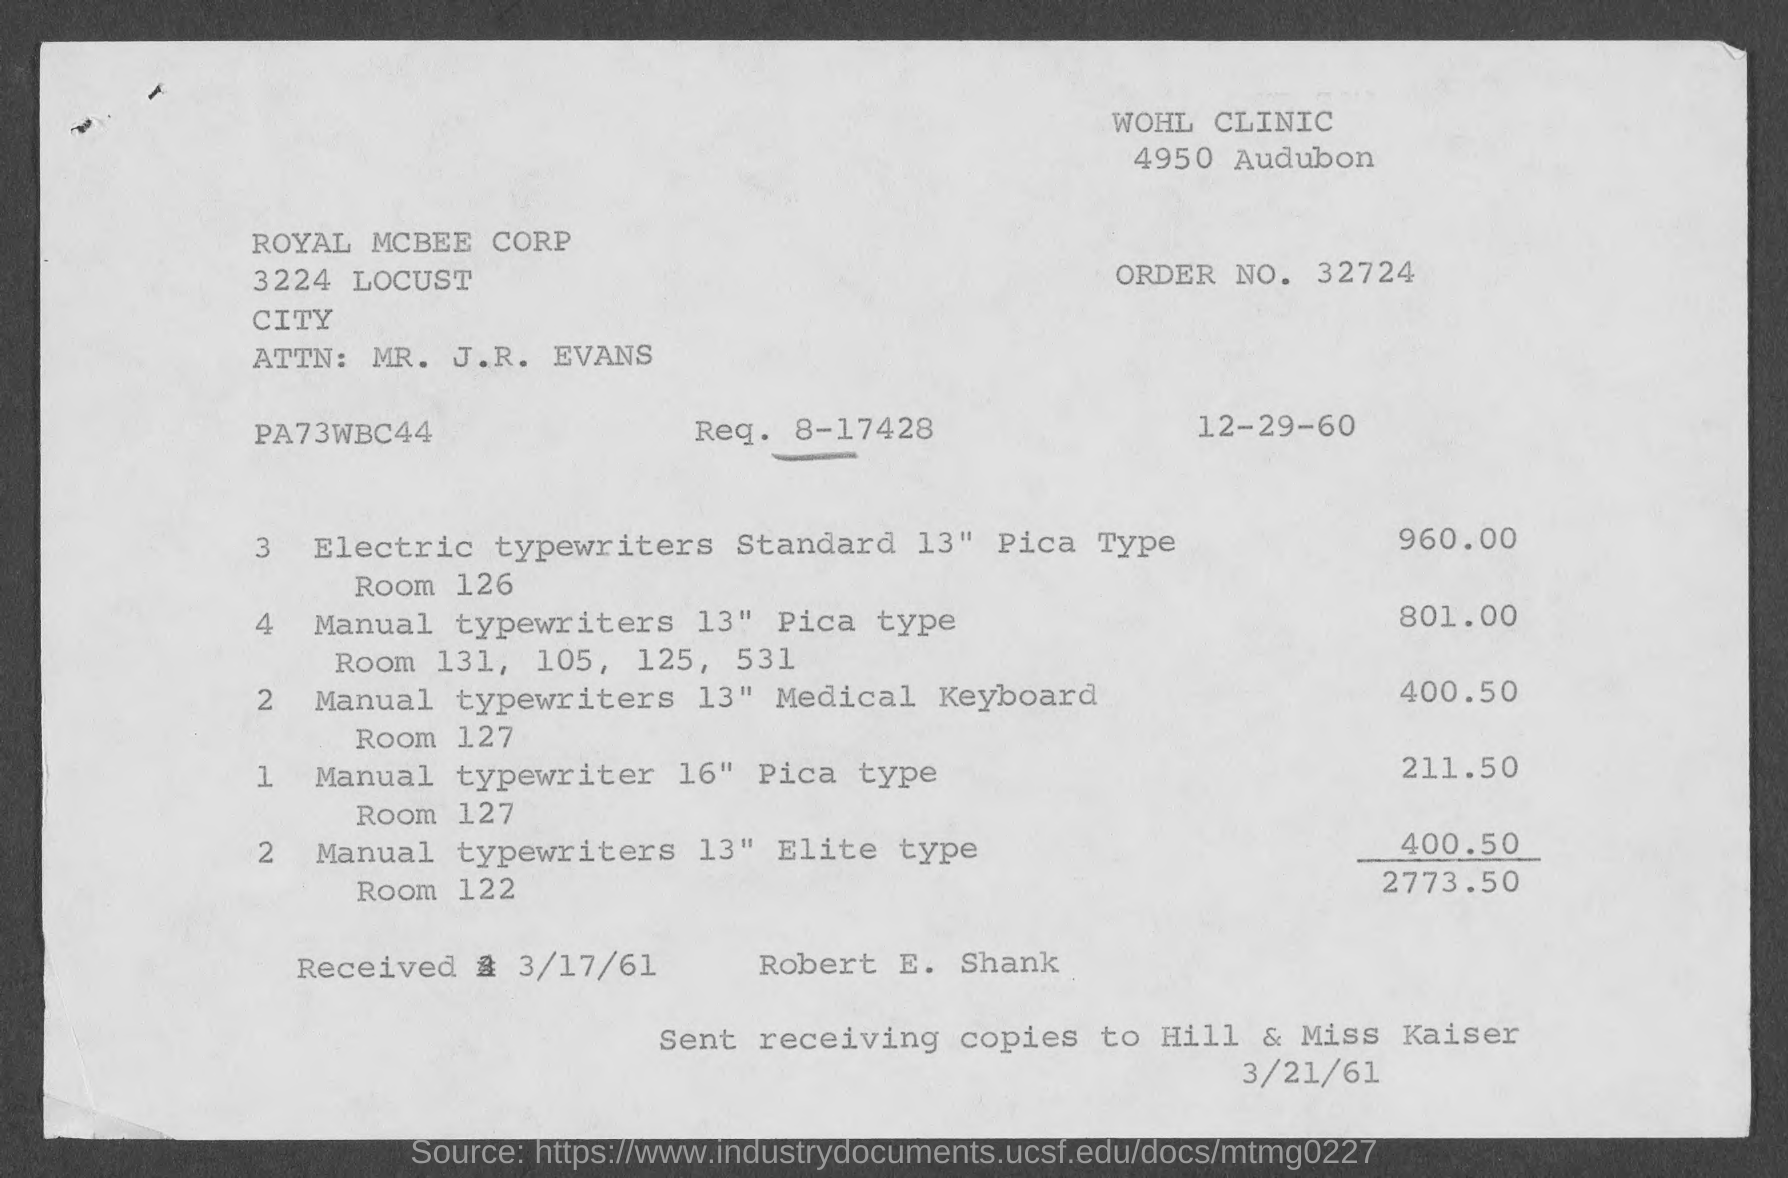What is the issued date of the invoice?
Your answer should be compact. 12-29-60. What is the Req. No. given in the invoice?
Provide a short and direct response. 8-17428. What is the Order No. given in the invoice?
Offer a very short reply. 32724. What is the received date mentioned in the invoice?
Ensure brevity in your answer.  3/17/61. Which company is raising the invoice?
Your response must be concise. ROYAL MCBEE CORP. What is the total invoice amount as per the document?
Your answer should be very brief. 2773.50. 